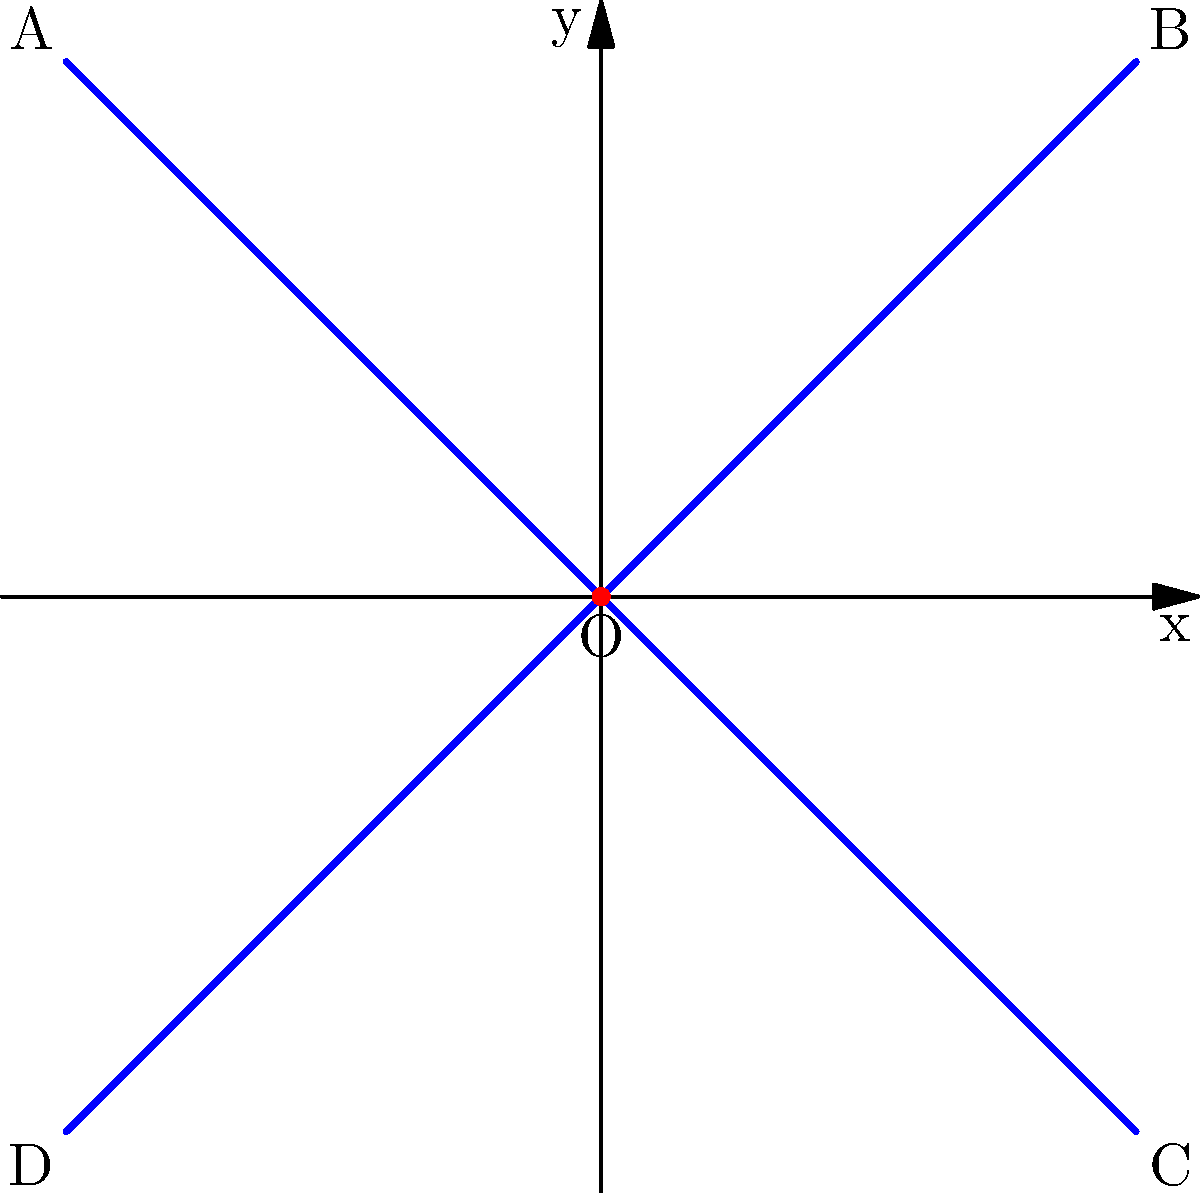In the coordinate plane above, a cross symbol is drawn to represent faith. The cross is formed by two perpendicular line segments intersecting at the origin O(0,0). If the endpoints of the cross are labeled A, B, C, and D as shown, what are the coordinates of point B? Let's approach this step-by-step:

1) We can see that the cross is symmetrical and centered at the origin O(0,0).

2) The cross extends equally in all four directions from the origin.

3) By observing the graph, we can see that the cross extends 2 units in each direction from the origin.

4) Point B is in the first quadrant, where both x and y coordinates are positive.

5) From the origin, point B is 2 units to the right (in the positive x direction) and 2 units up (in the positive y direction).

6) Therefore, the coordinates of point B are (2,2).
Answer: (2,2) 